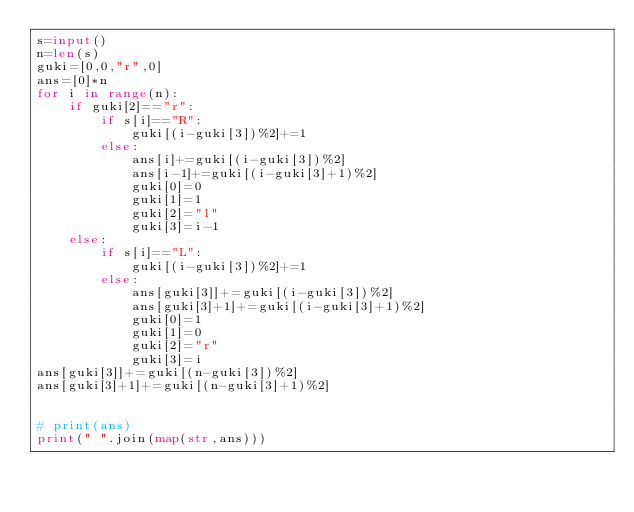Convert code to text. <code><loc_0><loc_0><loc_500><loc_500><_Python_>s=input()
n=len(s)
guki=[0,0,"r",0]
ans=[0]*n
for i in range(n):
    if guki[2]=="r":
        if s[i]=="R":
            guki[(i-guki[3])%2]+=1
        else:
            ans[i]+=guki[(i-guki[3])%2]
            ans[i-1]+=guki[(i-guki[3]+1)%2]
            guki[0]=0
            guki[1]=1
            guki[2]="l"
            guki[3]=i-1
    else:
        if s[i]=="L":
            guki[(i-guki[3])%2]+=1
        else:
            ans[guki[3]]+=guki[(i-guki[3])%2]
            ans[guki[3]+1]+=guki[(i-guki[3]+1)%2]
            guki[0]=1
            guki[1]=0
            guki[2]="r"
            guki[3]=i
ans[guki[3]]+=guki[(n-guki[3])%2]
ans[guki[3]+1]+=guki[(n-guki[3]+1)%2]


# print(ans)
print(" ".join(map(str,ans)))</code> 